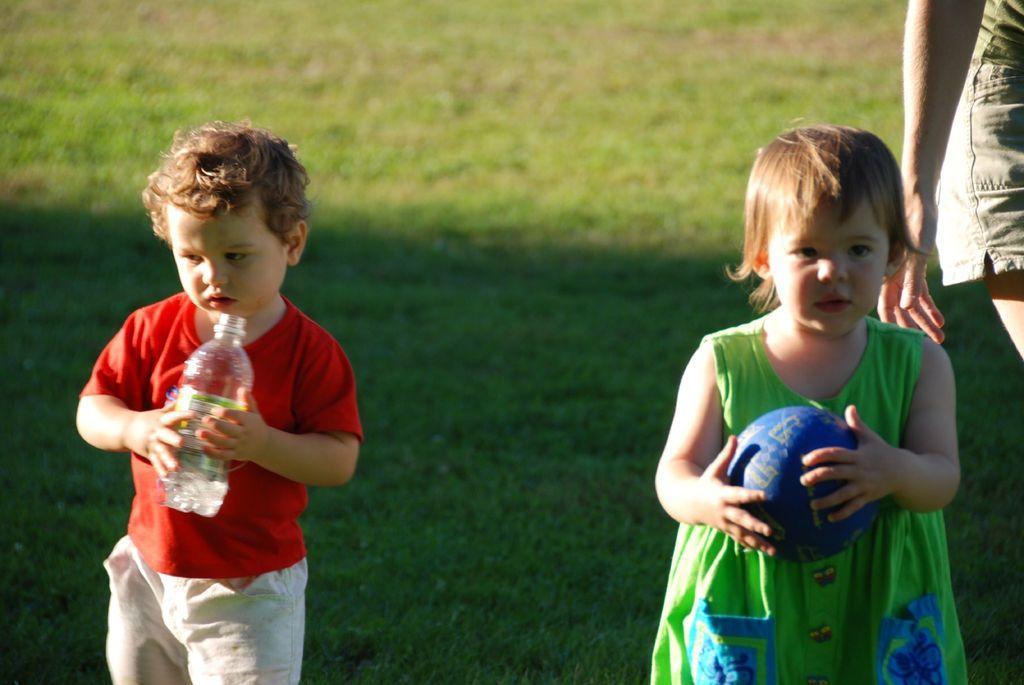Can you describe this image briefly? A boy is holding bottle in his hand and on the right a girls is holding ball in her hand beside there is a woman. Behind them we can see grass. 